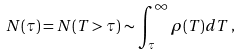Convert formula to latex. <formula><loc_0><loc_0><loc_500><loc_500>N ( \tau ) = N ( T > \tau ) \sim \int ^ { \infty } _ { \tau } \rho ( T ) d T \, ,</formula> 